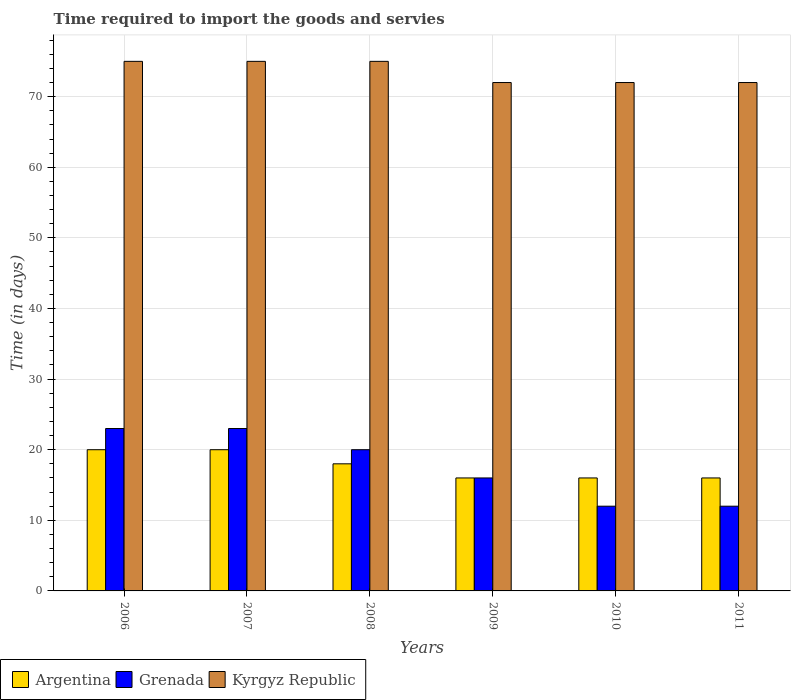How many different coloured bars are there?
Ensure brevity in your answer.  3. What is the label of the 5th group of bars from the left?
Provide a succinct answer. 2010. In how many cases, is the number of bars for a given year not equal to the number of legend labels?
Ensure brevity in your answer.  0. What is the number of days required to import the goods and services in Kyrgyz Republic in 2006?
Your response must be concise. 75. Across all years, what is the maximum number of days required to import the goods and services in Kyrgyz Republic?
Provide a succinct answer. 75. Across all years, what is the minimum number of days required to import the goods and services in Argentina?
Give a very brief answer. 16. In which year was the number of days required to import the goods and services in Grenada minimum?
Your answer should be very brief. 2010. What is the total number of days required to import the goods and services in Argentina in the graph?
Give a very brief answer. 106. What is the difference between the number of days required to import the goods and services in Kyrgyz Republic in 2006 and that in 2011?
Make the answer very short. 3. What is the difference between the number of days required to import the goods and services in Argentina in 2011 and the number of days required to import the goods and services in Kyrgyz Republic in 2009?
Provide a short and direct response. -56. What is the average number of days required to import the goods and services in Grenada per year?
Give a very brief answer. 17.67. In the year 2008, what is the difference between the number of days required to import the goods and services in Grenada and number of days required to import the goods and services in Argentina?
Your answer should be compact. 2. In how many years, is the number of days required to import the goods and services in Grenada greater than 38 days?
Give a very brief answer. 0. What is the ratio of the number of days required to import the goods and services in Argentina in 2009 to that in 2011?
Keep it short and to the point. 1. Is the difference between the number of days required to import the goods and services in Grenada in 2006 and 2007 greater than the difference between the number of days required to import the goods and services in Argentina in 2006 and 2007?
Provide a short and direct response. No. What is the difference between the highest and the second highest number of days required to import the goods and services in Grenada?
Keep it short and to the point. 0. What is the difference between the highest and the lowest number of days required to import the goods and services in Kyrgyz Republic?
Offer a terse response. 3. What does the 2nd bar from the left in 2006 represents?
Your response must be concise. Grenada. What does the 2nd bar from the right in 2008 represents?
Give a very brief answer. Grenada. Is it the case that in every year, the sum of the number of days required to import the goods and services in Argentina and number of days required to import the goods and services in Kyrgyz Republic is greater than the number of days required to import the goods and services in Grenada?
Provide a succinct answer. Yes. How many bars are there?
Make the answer very short. 18. Are all the bars in the graph horizontal?
Provide a succinct answer. No. Are the values on the major ticks of Y-axis written in scientific E-notation?
Ensure brevity in your answer.  No. Does the graph contain grids?
Your answer should be compact. Yes. How many legend labels are there?
Your answer should be compact. 3. What is the title of the graph?
Your answer should be compact. Time required to import the goods and servies. What is the label or title of the X-axis?
Provide a short and direct response. Years. What is the label or title of the Y-axis?
Offer a very short reply. Time (in days). What is the Time (in days) of Grenada in 2006?
Offer a very short reply. 23. What is the Time (in days) in Kyrgyz Republic in 2006?
Your answer should be very brief. 75. What is the Time (in days) in Kyrgyz Republic in 2007?
Make the answer very short. 75. What is the Time (in days) in Argentina in 2009?
Provide a short and direct response. 16. What is the Time (in days) in Grenada in 2009?
Make the answer very short. 16. What is the Time (in days) of Grenada in 2010?
Your response must be concise. 12. What is the Time (in days) in Kyrgyz Republic in 2010?
Your answer should be compact. 72. What is the Time (in days) in Grenada in 2011?
Your response must be concise. 12. What is the Time (in days) in Kyrgyz Republic in 2011?
Give a very brief answer. 72. Across all years, what is the maximum Time (in days) of Kyrgyz Republic?
Ensure brevity in your answer.  75. Across all years, what is the minimum Time (in days) of Argentina?
Provide a short and direct response. 16. What is the total Time (in days) in Argentina in the graph?
Offer a terse response. 106. What is the total Time (in days) of Grenada in the graph?
Give a very brief answer. 106. What is the total Time (in days) of Kyrgyz Republic in the graph?
Give a very brief answer. 441. What is the difference between the Time (in days) of Grenada in 2006 and that in 2007?
Ensure brevity in your answer.  0. What is the difference between the Time (in days) of Kyrgyz Republic in 2006 and that in 2007?
Offer a very short reply. 0. What is the difference between the Time (in days) of Grenada in 2006 and that in 2008?
Offer a terse response. 3. What is the difference between the Time (in days) of Kyrgyz Republic in 2006 and that in 2008?
Ensure brevity in your answer.  0. What is the difference between the Time (in days) in Kyrgyz Republic in 2006 and that in 2009?
Your response must be concise. 3. What is the difference between the Time (in days) in Grenada in 2006 and that in 2010?
Your answer should be very brief. 11. What is the difference between the Time (in days) of Kyrgyz Republic in 2006 and that in 2010?
Ensure brevity in your answer.  3. What is the difference between the Time (in days) in Argentina in 2006 and that in 2011?
Provide a short and direct response. 4. What is the difference between the Time (in days) of Grenada in 2006 and that in 2011?
Provide a short and direct response. 11. What is the difference between the Time (in days) of Kyrgyz Republic in 2006 and that in 2011?
Make the answer very short. 3. What is the difference between the Time (in days) in Grenada in 2007 and that in 2009?
Your response must be concise. 7. What is the difference between the Time (in days) of Grenada in 2007 and that in 2010?
Provide a short and direct response. 11. What is the difference between the Time (in days) of Argentina in 2007 and that in 2011?
Ensure brevity in your answer.  4. What is the difference between the Time (in days) of Kyrgyz Republic in 2007 and that in 2011?
Provide a succinct answer. 3. What is the difference between the Time (in days) in Grenada in 2008 and that in 2009?
Your response must be concise. 4. What is the difference between the Time (in days) of Argentina in 2008 and that in 2010?
Ensure brevity in your answer.  2. What is the difference between the Time (in days) in Kyrgyz Republic in 2008 and that in 2010?
Make the answer very short. 3. What is the difference between the Time (in days) of Argentina in 2008 and that in 2011?
Offer a terse response. 2. What is the difference between the Time (in days) of Kyrgyz Republic in 2008 and that in 2011?
Your answer should be very brief. 3. What is the difference between the Time (in days) in Argentina in 2009 and that in 2010?
Ensure brevity in your answer.  0. What is the difference between the Time (in days) of Argentina in 2009 and that in 2011?
Your answer should be very brief. 0. What is the difference between the Time (in days) of Argentina in 2010 and that in 2011?
Your answer should be very brief. 0. What is the difference between the Time (in days) in Grenada in 2010 and that in 2011?
Ensure brevity in your answer.  0. What is the difference between the Time (in days) of Argentina in 2006 and the Time (in days) of Grenada in 2007?
Your response must be concise. -3. What is the difference between the Time (in days) in Argentina in 2006 and the Time (in days) in Kyrgyz Republic in 2007?
Offer a very short reply. -55. What is the difference between the Time (in days) in Grenada in 2006 and the Time (in days) in Kyrgyz Republic in 2007?
Provide a short and direct response. -52. What is the difference between the Time (in days) in Argentina in 2006 and the Time (in days) in Grenada in 2008?
Your response must be concise. 0. What is the difference between the Time (in days) in Argentina in 2006 and the Time (in days) in Kyrgyz Republic in 2008?
Provide a succinct answer. -55. What is the difference between the Time (in days) in Grenada in 2006 and the Time (in days) in Kyrgyz Republic in 2008?
Ensure brevity in your answer.  -52. What is the difference between the Time (in days) of Argentina in 2006 and the Time (in days) of Grenada in 2009?
Offer a very short reply. 4. What is the difference between the Time (in days) of Argentina in 2006 and the Time (in days) of Kyrgyz Republic in 2009?
Your answer should be compact. -52. What is the difference between the Time (in days) in Grenada in 2006 and the Time (in days) in Kyrgyz Republic in 2009?
Give a very brief answer. -49. What is the difference between the Time (in days) of Argentina in 2006 and the Time (in days) of Grenada in 2010?
Provide a succinct answer. 8. What is the difference between the Time (in days) of Argentina in 2006 and the Time (in days) of Kyrgyz Republic in 2010?
Your answer should be compact. -52. What is the difference between the Time (in days) in Grenada in 2006 and the Time (in days) in Kyrgyz Republic in 2010?
Your response must be concise. -49. What is the difference between the Time (in days) of Argentina in 2006 and the Time (in days) of Grenada in 2011?
Your response must be concise. 8. What is the difference between the Time (in days) of Argentina in 2006 and the Time (in days) of Kyrgyz Republic in 2011?
Your response must be concise. -52. What is the difference between the Time (in days) of Grenada in 2006 and the Time (in days) of Kyrgyz Republic in 2011?
Offer a very short reply. -49. What is the difference between the Time (in days) in Argentina in 2007 and the Time (in days) in Kyrgyz Republic in 2008?
Your answer should be compact. -55. What is the difference between the Time (in days) in Grenada in 2007 and the Time (in days) in Kyrgyz Republic in 2008?
Your answer should be compact. -52. What is the difference between the Time (in days) of Argentina in 2007 and the Time (in days) of Kyrgyz Republic in 2009?
Make the answer very short. -52. What is the difference between the Time (in days) in Grenada in 2007 and the Time (in days) in Kyrgyz Republic in 2009?
Your answer should be compact. -49. What is the difference between the Time (in days) in Argentina in 2007 and the Time (in days) in Grenada in 2010?
Your answer should be compact. 8. What is the difference between the Time (in days) of Argentina in 2007 and the Time (in days) of Kyrgyz Republic in 2010?
Offer a terse response. -52. What is the difference between the Time (in days) of Grenada in 2007 and the Time (in days) of Kyrgyz Republic in 2010?
Your answer should be very brief. -49. What is the difference between the Time (in days) of Argentina in 2007 and the Time (in days) of Kyrgyz Republic in 2011?
Keep it short and to the point. -52. What is the difference between the Time (in days) in Grenada in 2007 and the Time (in days) in Kyrgyz Republic in 2011?
Your answer should be compact. -49. What is the difference between the Time (in days) in Argentina in 2008 and the Time (in days) in Kyrgyz Republic in 2009?
Give a very brief answer. -54. What is the difference between the Time (in days) in Grenada in 2008 and the Time (in days) in Kyrgyz Republic in 2009?
Your answer should be very brief. -52. What is the difference between the Time (in days) in Argentina in 2008 and the Time (in days) in Grenada in 2010?
Provide a short and direct response. 6. What is the difference between the Time (in days) in Argentina in 2008 and the Time (in days) in Kyrgyz Republic in 2010?
Ensure brevity in your answer.  -54. What is the difference between the Time (in days) in Grenada in 2008 and the Time (in days) in Kyrgyz Republic in 2010?
Keep it short and to the point. -52. What is the difference between the Time (in days) of Argentina in 2008 and the Time (in days) of Grenada in 2011?
Ensure brevity in your answer.  6. What is the difference between the Time (in days) in Argentina in 2008 and the Time (in days) in Kyrgyz Republic in 2011?
Make the answer very short. -54. What is the difference between the Time (in days) in Grenada in 2008 and the Time (in days) in Kyrgyz Republic in 2011?
Provide a short and direct response. -52. What is the difference between the Time (in days) of Argentina in 2009 and the Time (in days) of Grenada in 2010?
Offer a very short reply. 4. What is the difference between the Time (in days) in Argentina in 2009 and the Time (in days) in Kyrgyz Republic in 2010?
Ensure brevity in your answer.  -56. What is the difference between the Time (in days) in Grenada in 2009 and the Time (in days) in Kyrgyz Republic in 2010?
Keep it short and to the point. -56. What is the difference between the Time (in days) of Argentina in 2009 and the Time (in days) of Kyrgyz Republic in 2011?
Keep it short and to the point. -56. What is the difference between the Time (in days) of Grenada in 2009 and the Time (in days) of Kyrgyz Republic in 2011?
Ensure brevity in your answer.  -56. What is the difference between the Time (in days) in Argentina in 2010 and the Time (in days) in Grenada in 2011?
Provide a succinct answer. 4. What is the difference between the Time (in days) of Argentina in 2010 and the Time (in days) of Kyrgyz Republic in 2011?
Your answer should be very brief. -56. What is the difference between the Time (in days) of Grenada in 2010 and the Time (in days) of Kyrgyz Republic in 2011?
Offer a terse response. -60. What is the average Time (in days) in Argentina per year?
Ensure brevity in your answer.  17.67. What is the average Time (in days) of Grenada per year?
Make the answer very short. 17.67. What is the average Time (in days) of Kyrgyz Republic per year?
Ensure brevity in your answer.  73.5. In the year 2006, what is the difference between the Time (in days) in Argentina and Time (in days) in Kyrgyz Republic?
Your response must be concise. -55. In the year 2006, what is the difference between the Time (in days) in Grenada and Time (in days) in Kyrgyz Republic?
Your answer should be compact. -52. In the year 2007, what is the difference between the Time (in days) in Argentina and Time (in days) in Kyrgyz Republic?
Offer a terse response. -55. In the year 2007, what is the difference between the Time (in days) of Grenada and Time (in days) of Kyrgyz Republic?
Keep it short and to the point. -52. In the year 2008, what is the difference between the Time (in days) in Argentina and Time (in days) in Grenada?
Ensure brevity in your answer.  -2. In the year 2008, what is the difference between the Time (in days) in Argentina and Time (in days) in Kyrgyz Republic?
Offer a terse response. -57. In the year 2008, what is the difference between the Time (in days) of Grenada and Time (in days) of Kyrgyz Republic?
Your answer should be very brief. -55. In the year 2009, what is the difference between the Time (in days) in Argentina and Time (in days) in Grenada?
Your answer should be very brief. 0. In the year 2009, what is the difference between the Time (in days) of Argentina and Time (in days) of Kyrgyz Republic?
Provide a succinct answer. -56. In the year 2009, what is the difference between the Time (in days) in Grenada and Time (in days) in Kyrgyz Republic?
Ensure brevity in your answer.  -56. In the year 2010, what is the difference between the Time (in days) of Argentina and Time (in days) of Kyrgyz Republic?
Give a very brief answer. -56. In the year 2010, what is the difference between the Time (in days) in Grenada and Time (in days) in Kyrgyz Republic?
Keep it short and to the point. -60. In the year 2011, what is the difference between the Time (in days) in Argentina and Time (in days) in Kyrgyz Republic?
Provide a short and direct response. -56. In the year 2011, what is the difference between the Time (in days) in Grenada and Time (in days) in Kyrgyz Republic?
Make the answer very short. -60. What is the ratio of the Time (in days) of Argentina in 2006 to that in 2007?
Keep it short and to the point. 1. What is the ratio of the Time (in days) of Grenada in 2006 to that in 2008?
Offer a very short reply. 1.15. What is the ratio of the Time (in days) of Grenada in 2006 to that in 2009?
Make the answer very short. 1.44. What is the ratio of the Time (in days) of Kyrgyz Republic in 2006 to that in 2009?
Offer a very short reply. 1.04. What is the ratio of the Time (in days) of Argentina in 2006 to that in 2010?
Your answer should be very brief. 1.25. What is the ratio of the Time (in days) in Grenada in 2006 to that in 2010?
Your response must be concise. 1.92. What is the ratio of the Time (in days) in Kyrgyz Republic in 2006 to that in 2010?
Provide a short and direct response. 1.04. What is the ratio of the Time (in days) of Grenada in 2006 to that in 2011?
Provide a short and direct response. 1.92. What is the ratio of the Time (in days) in Kyrgyz Republic in 2006 to that in 2011?
Provide a succinct answer. 1.04. What is the ratio of the Time (in days) in Grenada in 2007 to that in 2008?
Your answer should be compact. 1.15. What is the ratio of the Time (in days) in Argentina in 2007 to that in 2009?
Provide a succinct answer. 1.25. What is the ratio of the Time (in days) of Grenada in 2007 to that in 2009?
Provide a succinct answer. 1.44. What is the ratio of the Time (in days) of Kyrgyz Republic in 2007 to that in 2009?
Give a very brief answer. 1.04. What is the ratio of the Time (in days) of Grenada in 2007 to that in 2010?
Offer a terse response. 1.92. What is the ratio of the Time (in days) of Kyrgyz Republic in 2007 to that in 2010?
Give a very brief answer. 1.04. What is the ratio of the Time (in days) of Argentina in 2007 to that in 2011?
Provide a succinct answer. 1.25. What is the ratio of the Time (in days) in Grenada in 2007 to that in 2011?
Make the answer very short. 1.92. What is the ratio of the Time (in days) of Kyrgyz Republic in 2007 to that in 2011?
Offer a terse response. 1.04. What is the ratio of the Time (in days) of Argentina in 2008 to that in 2009?
Give a very brief answer. 1.12. What is the ratio of the Time (in days) in Grenada in 2008 to that in 2009?
Ensure brevity in your answer.  1.25. What is the ratio of the Time (in days) of Kyrgyz Republic in 2008 to that in 2009?
Provide a short and direct response. 1.04. What is the ratio of the Time (in days) in Argentina in 2008 to that in 2010?
Ensure brevity in your answer.  1.12. What is the ratio of the Time (in days) in Grenada in 2008 to that in 2010?
Your answer should be very brief. 1.67. What is the ratio of the Time (in days) in Kyrgyz Republic in 2008 to that in 2010?
Ensure brevity in your answer.  1.04. What is the ratio of the Time (in days) in Kyrgyz Republic in 2008 to that in 2011?
Provide a succinct answer. 1.04. What is the ratio of the Time (in days) of Argentina in 2009 to that in 2010?
Offer a very short reply. 1. What is the ratio of the Time (in days) in Argentina in 2009 to that in 2011?
Provide a short and direct response. 1. What is the ratio of the Time (in days) of Kyrgyz Republic in 2009 to that in 2011?
Keep it short and to the point. 1. What is the difference between the highest and the second highest Time (in days) of Argentina?
Your answer should be compact. 0. What is the difference between the highest and the second highest Time (in days) in Grenada?
Your answer should be compact. 0. What is the difference between the highest and the second highest Time (in days) of Kyrgyz Republic?
Your response must be concise. 0. What is the difference between the highest and the lowest Time (in days) in Argentina?
Your answer should be very brief. 4. What is the difference between the highest and the lowest Time (in days) of Kyrgyz Republic?
Provide a short and direct response. 3. 